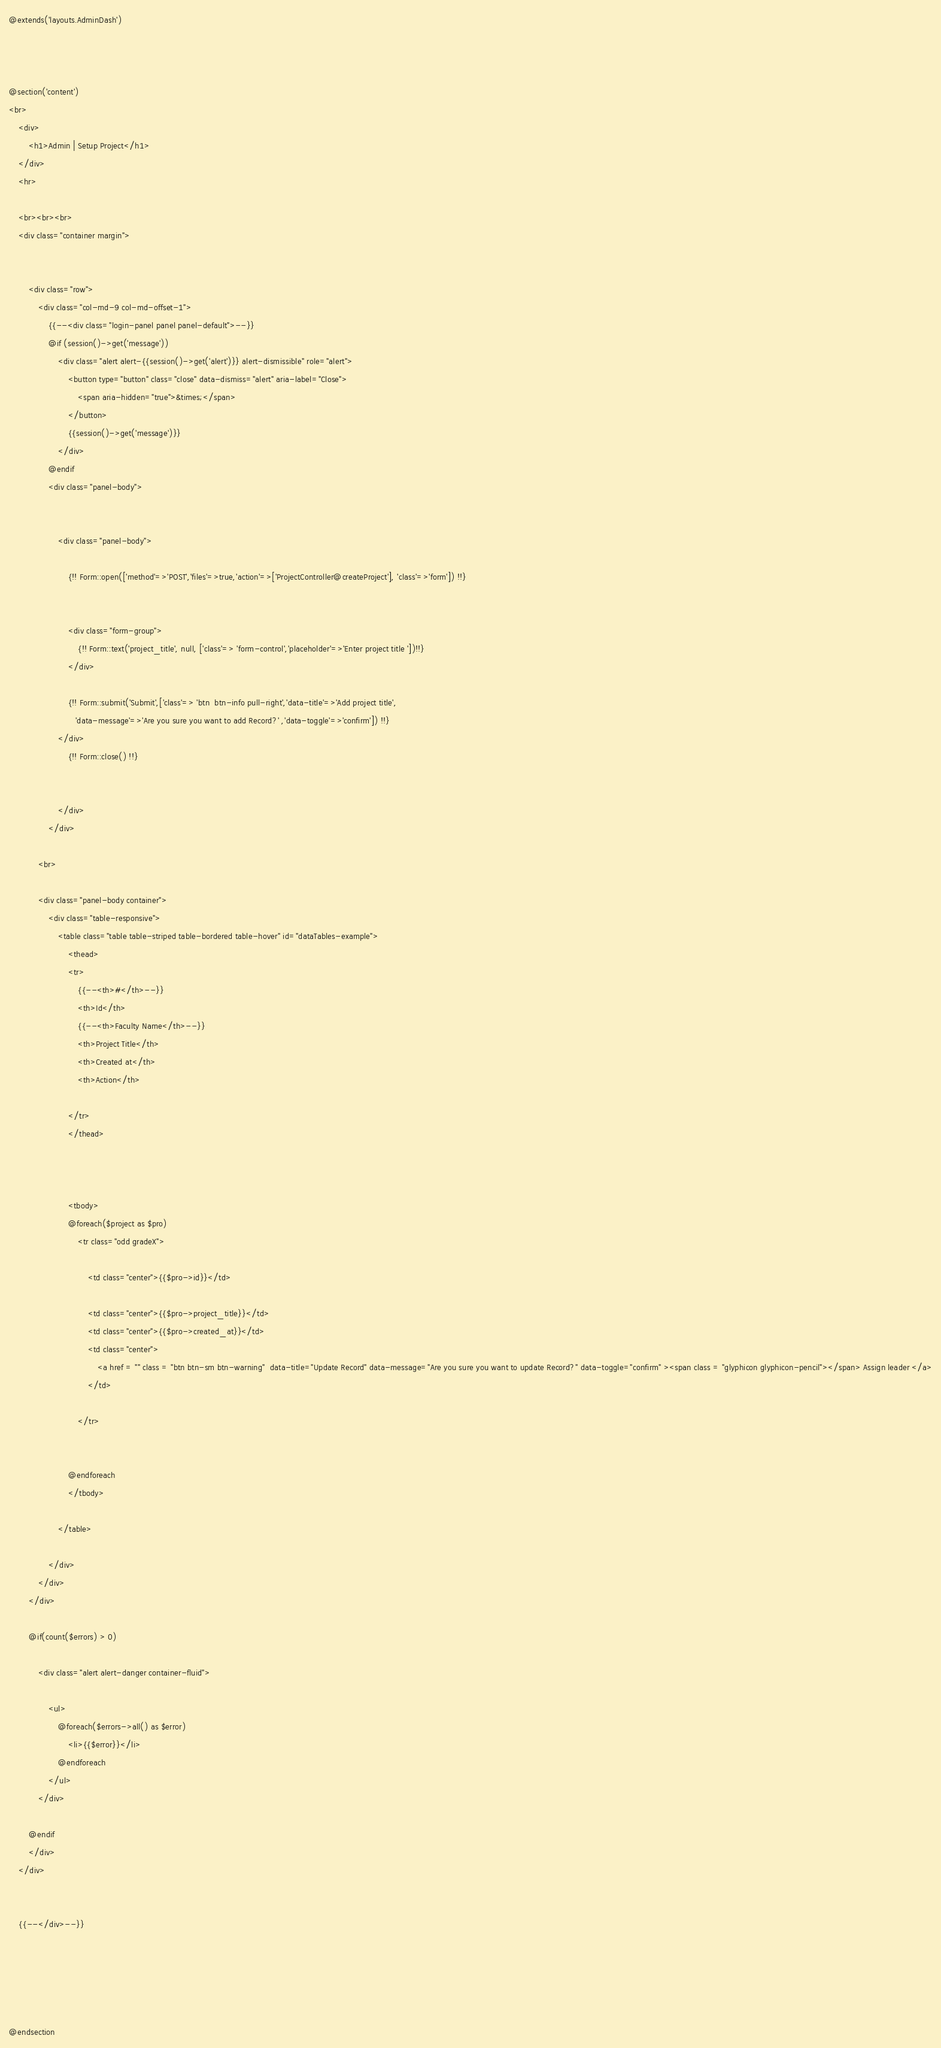<code> <loc_0><loc_0><loc_500><loc_500><_PHP_>@extends('layouts.AdminDash')



@section('content')
<br>
    <div>
        <h1>Admin | Setup Project</h1>
    </div>
    <hr>

    <br><br><br>
    <div class="container margin">


        <div class="row">
            <div class="col-md-9 col-md-offset-1">
                {{--<div class="login-panel panel panel-default">--}}
                @if (session()->get('message'))
                    <div class="alert alert-{{session()->get('alert')}} alert-dismissible" role="alert">
                        <button type="button" class="close" data-dismiss="alert" aria-label="Close">
                            <span aria-hidden="true">&times;</span>
                        </button>
                        {{session()->get('message')}}
                    </div>
                @endif
                <div class="panel-body">


                    <div class="panel-body">

                        {!! Form::open(['method'=>'POST','files'=>true,'action'=>['ProjectController@createProject'], 'class'=>'form']) !!}


                        <div class="form-group">
                            {!! Form::text('project_title', null, ['class'=> 'form-control','placeholder'=>'Enter project title '])!!}
                        </div>

                        {!! Form::submit('Submit',['class'=> 'btn  btn-info pull-right','data-title'=>'Add project title',
                           'data-message'=>'Are you sure you want to add Record?' ,'data-toggle'=>'confirm']) !!}
                    </div>
                        {!! Form::close() !!}


                    </div>
                </div>

            <br>

            <div class="panel-body container">
                <div class="table-responsive">
                    <table class="table table-striped table-bordered table-hover" id="dataTables-example">
                        <thead>
                        <tr>
                            {{--<th>#</th>--}}
                            <th>Id</th>
                            {{--<th>Faculty Name</th>--}}
                            <th>Project Title</th>
                            <th>Created at</th>
                            <th>Action</th>

                        </tr>
                        </thead>



                        <tbody>
                        @foreach($project as $pro)
                            <tr class="odd gradeX">

                                <td class="center">{{$pro->id}}</td>

                                <td class="center">{{$pro->project_title}}</td>
                                <td class="center">{{$pro->created_at}}</td>
                                <td class="center">
                                    <a href = "" class = "btn btn-sm btn-warning"  data-title="Update Record" data-message="Are you sure you want to update Record?" data-toggle="confirm" ><span class = "glyphicon glyphicon-pencil"></span> Assign leader </a>
                                </td>

                            </tr>


                        @endforeach
                        </tbody>

                    </table>

                </div>
            </div>
        </div>

        @if(count($errors) > 0)

            <div class="alert alert-danger container-fluid">

                <ul>
                    @foreach($errors->all() as $error)
                        <li>{{$error}}</li>
                    @endforeach
                </ul>
            </div>

        @endif
        </div>
    </div>


    {{--</div>--}}





@endsection</code> 